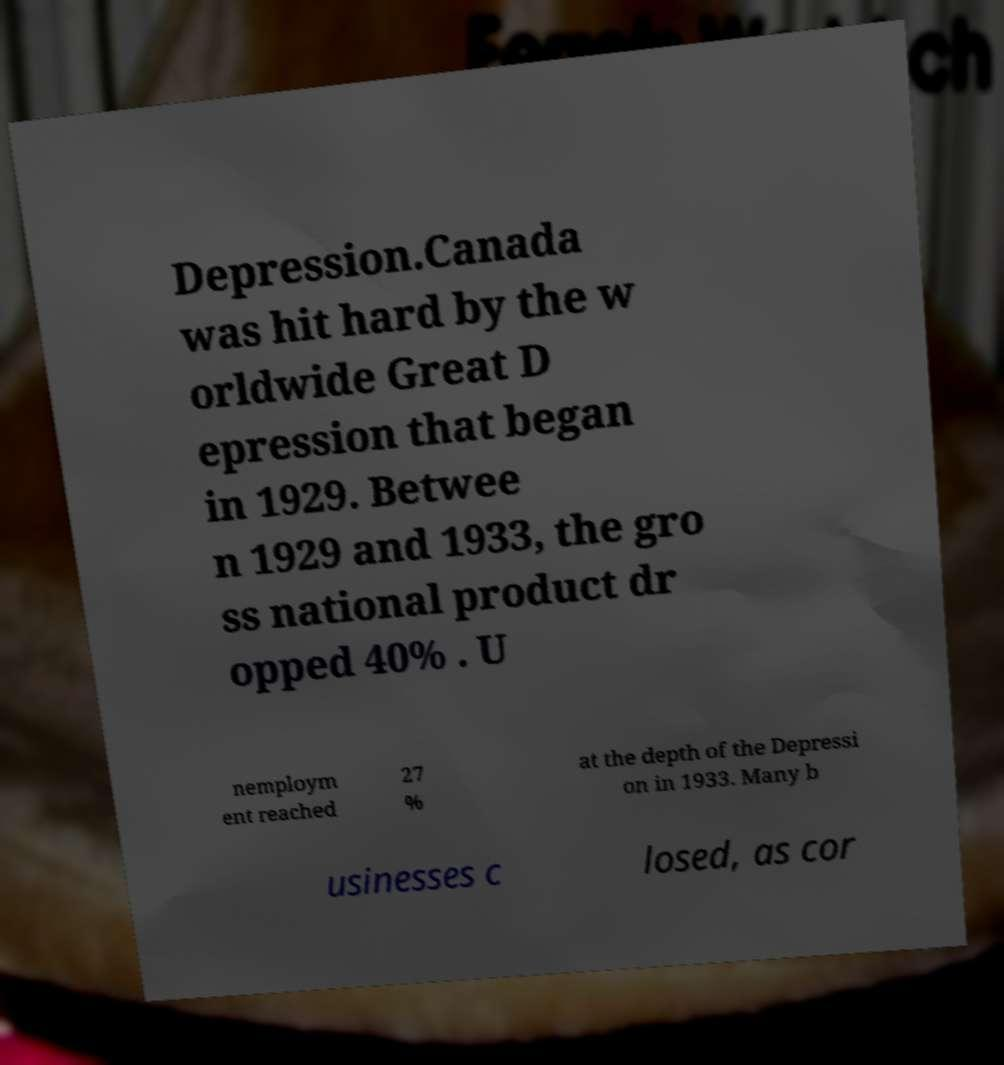I need the written content from this picture converted into text. Can you do that? Depression.Canada was hit hard by the w orldwide Great D epression that began in 1929. Betwee n 1929 and 1933, the gro ss national product dr opped 40% . U nemploym ent reached 27 % at the depth of the Depressi on in 1933. Many b usinesses c losed, as cor 